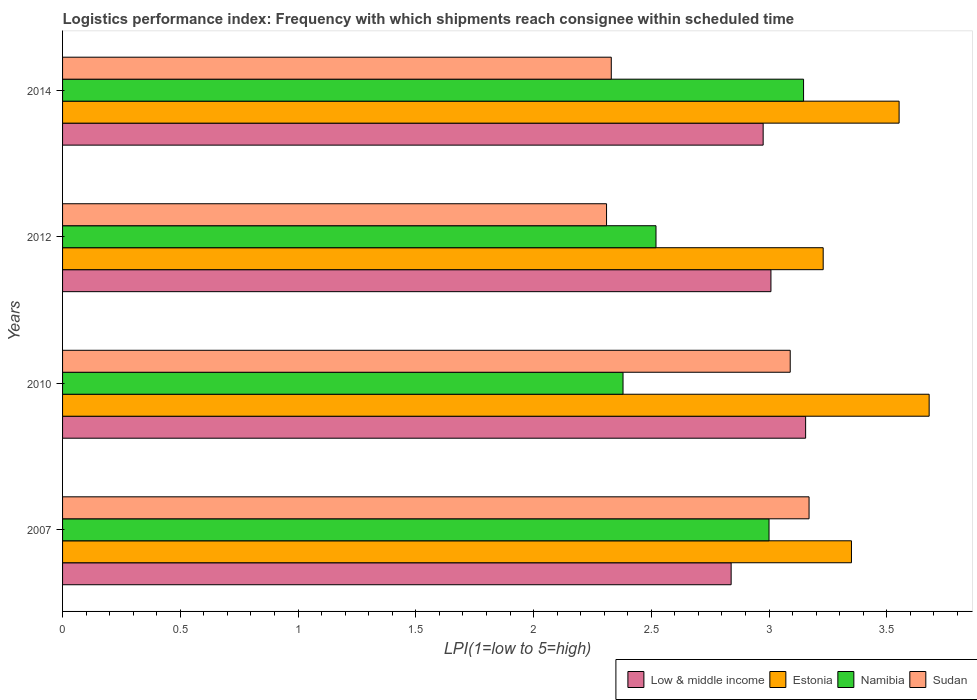How many groups of bars are there?
Your answer should be compact. 4. Are the number of bars per tick equal to the number of legend labels?
Give a very brief answer. Yes. How many bars are there on the 3rd tick from the bottom?
Keep it short and to the point. 4. What is the label of the 3rd group of bars from the top?
Ensure brevity in your answer.  2010. In how many cases, is the number of bars for a given year not equal to the number of legend labels?
Keep it short and to the point. 0. What is the logistics performance index in Estonia in 2014?
Make the answer very short. 3.55. Across all years, what is the maximum logistics performance index in Sudan?
Provide a succinct answer. 3.17. Across all years, what is the minimum logistics performance index in Namibia?
Provide a succinct answer. 2.38. In which year was the logistics performance index in Estonia maximum?
Offer a very short reply. 2010. What is the total logistics performance index in Sudan in the graph?
Your response must be concise. 10.9. What is the difference between the logistics performance index in Namibia in 2010 and that in 2012?
Provide a short and direct response. -0.14. What is the difference between the logistics performance index in Low & middle income in 2007 and the logistics performance index in Namibia in 2012?
Your answer should be very brief. 0.32. What is the average logistics performance index in Estonia per year?
Your answer should be very brief. 3.45. In the year 2014, what is the difference between the logistics performance index in Sudan and logistics performance index in Estonia?
Your response must be concise. -1.22. What is the ratio of the logistics performance index in Namibia in 2007 to that in 2012?
Provide a succinct answer. 1.19. Is the difference between the logistics performance index in Sudan in 2007 and 2010 greater than the difference between the logistics performance index in Estonia in 2007 and 2010?
Keep it short and to the point. Yes. What is the difference between the highest and the second highest logistics performance index in Estonia?
Ensure brevity in your answer.  0.13. What is the difference between the highest and the lowest logistics performance index in Sudan?
Your response must be concise. 0.86. In how many years, is the logistics performance index in Sudan greater than the average logistics performance index in Sudan taken over all years?
Offer a very short reply. 2. Is it the case that in every year, the sum of the logistics performance index in Low & middle income and logistics performance index in Sudan is greater than the sum of logistics performance index in Namibia and logistics performance index in Estonia?
Make the answer very short. No. What does the 2nd bar from the top in 2010 represents?
Offer a very short reply. Namibia. What does the 2nd bar from the bottom in 2010 represents?
Give a very brief answer. Estonia. Is it the case that in every year, the sum of the logistics performance index in Low & middle income and logistics performance index in Sudan is greater than the logistics performance index in Namibia?
Offer a very short reply. Yes. How many bars are there?
Your response must be concise. 16. Are the values on the major ticks of X-axis written in scientific E-notation?
Your answer should be compact. No. Does the graph contain grids?
Your answer should be very brief. No. Where does the legend appear in the graph?
Give a very brief answer. Bottom right. What is the title of the graph?
Your answer should be very brief. Logistics performance index: Frequency with which shipments reach consignee within scheduled time. What is the label or title of the X-axis?
Keep it short and to the point. LPI(1=low to 5=high). What is the label or title of the Y-axis?
Your response must be concise. Years. What is the LPI(1=low to 5=high) in Low & middle income in 2007?
Provide a succinct answer. 2.84. What is the LPI(1=low to 5=high) of Estonia in 2007?
Your response must be concise. 3.35. What is the LPI(1=low to 5=high) in Namibia in 2007?
Give a very brief answer. 3. What is the LPI(1=low to 5=high) in Sudan in 2007?
Provide a short and direct response. 3.17. What is the LPI(1=low to 5=high) of Low & middle income in 2010?
Keep it short and to the point. 3.16. What is the LPI(1=low to 5=high) in Estonia in 2010?
Make the answer very short. 3.68. What is the LPI(1=low to 5=high) in Namibia in 2010?
Offer a very short reply. 2.38. What is the LPI(1=low to 5=high) of Sudan in 2010?
Ensure brevity in your answer.  3.09. What is the LPI(1=low to 5=high) of Low & middle income in 2012?
Make the answer very short. 3.01. What is the LPI(1=low to 5=high) of Estonia in 2012?
Provide a succinct answer. 3.23. What is the LPI(1=low to 5=high) of Namibia in 2012?
Give a very brief answer. 2.52. What is the LPI(1=low to 5=high) in Sudan in 2012?
Provide a succinct answer. 2.31. What is the LPI(1=low to 5=high) in Low & middle income in 2014?
Provide a short and direct response. 2.98. What is the LPI(1=low to 5=high) of Estonia in 2014?
Ensure brevity in your answer.  3.55. What is the LPI(1=low to 5=high) of Namibia in 2014?
Offer a very short reply. 3.15. What is the LPI(1=low to 5=high) in Sudan in 2014?
Give a very brief answer. 2.33. Across all years, what is the maximum LPI(1=low to 5=high) in Low & middle income?
Ensure brevity in your answer.  3.16. Across all years, what is the maximum LPI(1=low to 5=high) of Estonia?
Your answer should be compact. 3.68. Across all years, what is the maximum LPI(1=low to 5=high) of Namibia?
Give a very brief answer. 3.15. Across all years, what is the maximum LPI(1=low to 5=high) of Sudan?
Make the answer very short. 3.17. Across all years, what is the minimum LPI(1=low to 5=high) of Low & middle income?
Provide a short and direct response. 2.84. Across all years, what is the minimum LPI(1=low to 5=high) in Estonia?
Your answer should be very brief. 3.23. Across all years, what is the minimum LPI(1=low to 5=high) of Namibia?
Offer a very short reply. 2.38. Across all years, what is the minimum LPI(1=low to 5=high) in Sudan?
Keep it short and to the point. 2.31. What is the total LPI(1=low to 5=high) of Low & middle income in the graph?
Provide a short and direct response. 11.98. What is the total LPI(1=low to 5=high) of Estonia in the graph?
Your answer should be very brief. 13.81. What is the total LPI(1=low to 5=high) of Namibia in the graph?
Make the answer very short. 11.05. What is the total LPI(1=low to 5=high) of Sudan in the graph?
Give a very brief answer. 10.9. What is the difference between the LPI(1=low to 5=high) of Low & middle income in 2007 and that in 2010?
Offer a very short reply. -0.32. What is the difference between the LPI(1=low to 5=high) of Estonia in 2007 and that in 2010?
Provide a succinct answer. -0.33. What is the difference between the LPI(1=low to 5=high) in Namibia in 2007 and that in 2010?
Ensure brevity in your answer.  0.62. What is the difference between the LPI(1=low to 5=high) of Sudan in 2007 and that in 2010?
Your answer should be very brief. 0.08. What is the difference between the LPI(1=low to 5=high) of Low & middle income in 2007 and that in 2012?
Offer a very short reply. -0.17. What is the difference between the LPI(1=low to 5=high) of Estonia in 2007 and that in 2012?
Your answer should be very brief. 0.12. What is the difference between the LPI(1=low to 5=high) of Namibia in 2007 and that in 2012?
Offer a very short reply. 0.48. What is the difference between the LPI(1=low to 5=high) in Sudan in 2007 and that in 2012?
Provide a short and direct response. 0.86. What is the difference between the LPI(1=low to 5=high) in Low & middle income in 2007 and that in 2014?
Provide a succinct answer. -0.14. What is the difference between the LPI(1=low to 5=high) in Estonia in 2007 and that in 2014?
Your response must be concise. -0.2. What is the difference between the LPI(1=low to 5=high) of Namibia in 2007 and that in 2014?
Your answer should be very brief. -0.15. What is the difference between the LPI(1=low to 5=high) of Sudan in 2007 and that in 2014?
Your answer should be very brief. 0.84. What is the difference between the LPI(1=low to 5=high) of Low & middle income in 2010 and that in 2012?
Your answer should be very brief. 0.15. What is the difference between the LPI(1=low to 5=high) of Estonia in 2010 and that in 2012?
Offer a very short reply. 0.45. What is the difference between the LPI(1=low to 5=high) of Namibia in 2010 and that in 2012?
Your response must be concise. -0.14. What is the difference between the LPI(1=low to 5=high) of Sudan in 2010 and that in 2012?
Your answer should be compact. 0.78. What is the difference between the LPI(1=low to 5=high) in Low & middle income in 2010 and that in 2014?
Your response must be concise. 0.18. What is the difference between the LPI(1=low to 5=high) in Estonia in 2010 and that in 2014?
Your answer should be compact. 0.13. What is the difference between the LPI(1=low to 5=high) in Namibia in 2010 and that in 2014?
Keep it short and to the point. -0.77. What is the difference between the LPI(1=low to 5=high) in Sudan in 2010 and that in 2014?
Give a very brief answer. 0.76. What is the difference between the LPI(1=low to 5=high) in Low & middle income in 2012 and that in 2014?
Offer a terse response. 0.03. What is the difference between the LPI(1=low to 5=high) in Estonia in 2012 and that in 2014?
Provide a succinct answer. -0.32. What is the difference between the LPI(1=low to 5=high) in Namibia in 2012 and that in 2014?
Your answer should be compact. -0.63. What is the difference between the LPI(1=low to 5=high) in Sudan in 2012 and that in 2014?
Give a very brief answer. -0.02. What is the difference between the LPI(1=low to 5=high) of Low & middle income in 2007 and the LPI(1=low to 5=high) of Estonia in 2010?
Keep it short and to the point. -0.84. What is the difference between the LPI(1=low to 5=high) of Low & middle income in 2007 and the LPI(1=low to 5=high) of Namibia in 2010?
Give a very brief answer. 0.46. What is the difference between the LPI(1=low to 5=high) in Low & middle income in 2007 and the LPI(1=low to 5=high) in Sudan in 2010?
Your response must be concise. -0.25. What is the difference between the LPI(1=low to 5=high) of Estonia in 2007 and the LPI(1=low to 5=high) of Sudan in 2010?
Keep it short and to the point. 0.26. What is the difference between the LPI(1=low to 5=high) of Namibia in 2007 and the LPI(1=low to 5=high) of Sudan in 2010?
Your response must be concise. -0.09. What is the difference between the LPI(1=low to 5=high) of Low & middle income in 2007 and the LPI(1=low to 5=high) of Estonia in 2012?
Your response must be concise. -0.39. What is the difference between the LPI(1=low to 5=high) of Low & middle income in 2007 and the LPI(1=low to 5=high) of Namibia in 2012?
Keep it short and to the point. 0.32. What is the difference between the LPI(1=low to 5=high) of Low & middle income in 2007 and the LPI(1=low to 5=high) of Sudan in 2012?
Provide a succinct answer. 0.53. What is the difference between the LPI(1=low to 5=high) of Estonia in 2007 and the LPI(1=low to 5=high) of Namibia in 2012?
Give a very brief answer. 0.83. What is the difference between the LPI(1=low to 5=high) of Namibia in 2007 and the LPI(1=low to 5=high) of Sudan in 2012?
Your answer should be compact. 0.69. What is the difference between the LPI(1=low to 5=high) in Low & middle income in 2007 and the LPI(1=low to 5=high) in Estonia in 2014?
Offer a very short reply. -0.71. What is the difference between the LPI(1=low to 5=high) of Low & middle income in 2007 and the LPI(1=low to 5=high) of Namibia in 2014?
Ensure brevity in your answer.  -0.31. What is the difference between the LPI(1=low to 5=high) in Low & middle income in 2007 and the LPI(1=low to 5=high) in Sudan in 2014?
Give a very brief answer. 0.51. What is the difference between the LPI(1=low to 5=high) in Estonia in 2007 and the LPI(1=low to 5=high) in Namibia in 2014?
Your answer should be compact. 0.2. What is the difference between the LPI(1=low to 5=high) of Estonia in 2007 and the LPI(1=low to 5=high) of Sudan in 2014?
Your response must be concise. 1.02. What is the difference between the LPI(1=low to 5=high) in Namibia in 2007 and the LPI(1=low to 5=high) in Sudan in 2014?
Your answer should be very brief. 0.67. What is the difference between the LPI(1=low to 5=high) of Low & middle income in 2010 and the LPI(1=low to 5=high) of Estonia in 2012?
Offer a terse response. -0.07. What is the difference between the LPI(1=low to 5=high) in Low & middle income in 2010 and the LPI(1=low to 5=high) in Namibia in 2012?
Make the answer very short. 0.64. What is the difference between the LPI(1=low to 5=high) of Low & middle income in 2010 and the LPI(1=low to 5=high) of Sudan in 2012?
Provide a succinct answer. 0.85. What is the difference between the LPI(1=low to 5=high) in Estonia in 2010 and the LPI(1=low to 5=high) in Namibia in 2012?
Your answer should be compact. 1.16. What is the difference between the LPI(1=low to 5=high) in Estonia in 2010 and the LPI(1=low to 5=high) in Sudan in 2012?
Your answer should be compact. 1.37. What is the difference between the LPI(1=low to 5=high) of Namibia in 2010 and the LPI(1=low to 5=high) of Sudan in 2012?
Provide a short and direct response. 0.07. What is the difference between the LPI(1=low to 5=high) in Low & middle income in 2010 and the LPI(1=low to 5=high) in Estonia in 2014?
Your answer should be very brief. -0.4. What is the difference between the LPI(1=low to 5=high) of Low & middle income in 2010 and the LPI(1=low to 5=high) of Namibia in 2014?
Make the answer very short. 0.01. What is the difference between the LPI(1=low to 5=high) in Low & middle income in 2010 and the LPI(1=low to 5=high) in Sudan in 2014?
Your answer should be very brief. 0.83. What is the difference between the LPI(1=low to 5=high) of Estonia in 2010 and the LPI(1=low to 5=high) of Namibia in 2014?
Your response must be concise. 0.53. What is the difference between the LPI(1=low to 5=high) in Estonia in 2010 and the LPI(1=low to 5=high) in Sudan in 2014?
Ensure brevity in your answer.  1.35. What is the difference between the LPI(1=low to 5=high) of Namibia in 2010 and the LPI(1=low to 5=high) of Sudan in 2014?
Your answer should be very brief. 0.05. What is the difference between the LPI(1=low to 5=high) in Low & middle income in 2012 and the LPI(1=low to 5=high) in Estonia in 2014?
Provide a succinct answer. -0.54. What is the difference between the LPI(1=low to 5=high) of Low & middle income in 2012 and the LPI(1=low to 5=high) of Namibia in 2014?
Offer a terse response. -0.14. What is the difference between the LPI(1=low to 5=high) of Low & middle income in 2012 and the LPI(1=low to 5=high) of Sudan in 2014?
Keep it short and to the point. 0.68. What is the difference between the LPI(1=low to 5=high) in Estonia in 2012 and the LPI(1=low to 5=high) in Namibia in 2014?
Offer a very short reply. 0.08. What is the difference between the LPI(1=low to 5=high) in Estonia in 2012 and the LPI(1=low to 5=high) in Sudan in 2014?
Your answer should be very brief. 0.9. What is the difference between the LPI(1=low to 5=high) in Namibia in 2012 and the LPI(1=low to 5=high) in Sudan in 2014?
Offer a terse response. 0.19. What is the average LPI(1=low to 5=high) in Low & middle income per year?
Provide a succinct answer. 2.99. What is the average LPI(1=low to 5=high) of Estonia per year?
Your answer should be compact. 3.45. What is the average LPI(1=low to 5=high) of Namibia per year?
Your answer should be very brief. 2.76. What is the average LPI(1=low to 5=high) in Sudan per year?
Provide a succinct answer. 2.73. In the year 2007, what is the difference between the LPI(1=low to 5=high) of Low & middle income and LPI(1=low to 5=high) of Estonia?
Keep it short and to the point. -0.51. In the year 2007, what is the difference between the LPI(1=low to 5=high) in Low & middle income and LPI(1=low to 5=high) in Namibia?
Keep it short and to the point. -0.16. In the year 2007, what is the difference between the LPI(1=low to 5=high) in Low & middle income and LPI(1=low to 5=high) in Sudan?
Ensure brevity in your answer.  -0.33. In the year 2007, what is the difference between the LPI(1=low to 5=high) of Estonia and LPI(1=low to 5=high) of Namibia?
Make the answer very short. 0.35. In the year 2007, what is the difference between the LPI(1=low to 5=high) of Estonia and LPI(1=low to 5=high) of Sudan?
Offer a terse response. 0.18. In the year 2007, what is the difference between the LPI(1=low to 5=high) of Namibia and LPI(1=low to 5=high) of Sudan?
Provide a short and direct response. -0.17. In the year 2010, what is the difference between the LPI(1=low to 5=high) of Low & middle income and LPI(1=low to 5=high) of Estonia?
Provide a short and direct response. -0.52. In the year 2010, what is the difference between the LPI(1=low to 5=high) of Low & middle income and LPI(1=low to 5=high) of Namibia?
Offer a very short reply. 0.78. In the year 2010, what is the difference between the LPI(1=low to 5=high) in Low & middle income and LPI(1=low to 5=high) in Sudan?
Your answer should be compact. 0.07. In the year 2010, what is the difference between the LPI(1=low to 5=high) in Estonia and LPI(1=low to 5=high) in Namibia?
Provide a short and direct response. 1.3. In the year 2010, what is the difference between the LPI(1=low to 5=high) in Estonia and LPI(1=low to 5=high) in Sudan?
Your response must be concise. 0.59. In the year 2010, what is the difference between the LPI(1=low to 5=high) of Namibia and LPI(1=low to 5=high) of Sudan?
Give a very brief answer. -0.71. In the year 2012, what is the difference between the LPI(1=low to 5=high) of Low & middle income and LPI(1=low to 5=high) of Estonia?
Ensure brevity in your answer.  -0.22. In the year 2012, what is the difference between the LPI(1=low to 5=high) in Low & middle income and LPI(1=low to 5=high) in Namibia?
Make the answer very short. 0.49. In the year 2012, what is the difference between the LPI(1=low to 5=high) of Low & middle income and LPI(1=low to 5=high) of Sudan?
Your response must be concise. 0.7. In the year 2012, what is the difference between the LPI(1=low to 5=high) in Estonia and LPI(1=low to 5=high) in Namibia?
Offer a very short reply. 0.71. In the year 2012, what is the difference between the LPI(1=low to 5=high) of Namibia and LPI(1=low to 5=high) of Sudan?
Offer a terse response. 0.21. In the year 2014, what is the difference between the LPI(1=low to 5=high) in Low & middle income and LPI(1=low to 5=high) in Estonia?
Offer a terse response. -0.58. In the year 2014, what is the difference between the LPI(1=low to 5=high) in Low & middle income and LPI(1=low to 5=high) in Namibia?
Keep it short and to the point. -0.17. In the year 2014, what is the difference between the LPI(1=low to 5=high) of Low & middle income and LPI(1=low to 5=high) of Sudan?
Give a very brief answer. 0.65. In the year 2014, what is the difference between the LPI(1=low to 5=high) in Estonia and LPI(1=low to 5=high) in Namibia?
Offer a terse response. 0.41. In the year 2014, what is the difference between the LPI(1=low to 5=high) of Estonia and LPI(1=low to 5=high) of Sudan?
Your response must be concise. 1.22. In the year 2014, what is the difference between the LPI(1=low to 5=high) in Namibia and LPI(1=low to 5=high) in Sudan?
Offer a terse response. 0.82. What is the ratio of the LPI(1=low to 5=high) of Low & middle income in 2007 to that in 2010?
Provide a succinct answer. 0.9. What is the ratio of the LPI(1=low to 5=high) in Estonia in 2007 to that in 2010?
Ensure brevity in your answer.  0.91. What is the ratio of the LPI(1=low to 5=high) in Namibia in 2007 to that in 2010?
Give a very brief answer. 1.26. What is the ratio of the LPI(1=low to 5=high) in Sudan in 2007 to that in 2010?
Your answer should be compact. 1.03. What is the ratio of the LPI(1=low to 5=high) in Low & middle income in 2007 to that in 2012?
Your response must be concise. 0.94. What is the ratio of the LPI(1=low to 5=high) in Estonia in 2007 to that in 2012?
Make the answer very short. 1.04. What is the ratio of the LPI(1=low to 5=high) of Namibia in 2007 to that in 2012?
Provide a succinct answer. 1.19. What is the ratio of the LPI(1=low to 5=high) of Sudan in 2007 to that in 2012?
Your response must be concise. 1.37. What is the ratio of the LPI(1=low to 5=high) of Low & middle income in 2007 to that in 2014?
Give a very brief answer. 0.95. What is the ratio of the LPI(1=low to 5=high) in Estonia in 2007 to that in 2014?
Your response must be concise. 0.94. What is the ratio of the LPI(1=low to 5=high) of Namibia in 2007 to that in 2014?
Your answer should be very brief. 0.95. What is the ratio of the LPI(1=low to 5=high) in Sudan in 2007 to that in 2014?
Provide a short and direct response. 1.36. What is the ratio of the LPI(1=low to 5=high) of Low & middle income in 2010 to that in 2012?
Your answer should be very brief. 1.05. What is the ratio of the LPI(1=low to 5=high) in Estonia in 2010 to that in 2012?
Your response must be concise. 1.14. What is the ratio of the LPI(1=low to 5=high) of Sudan in 2010 to that in 2012?
Provide a succinct answer. 1.34. What is the ratio of the LPI(1=low to 5=high) of Low & middle income in 2010 to that in 2014?
Your response must be concise. 1.06. What is the ratio of the LPI(1=low to 5=high) of Estonia in 2010 to that in 2014?
Make the answer very short. 1.04. What is the ratio of the LPI(1=low to 5=high) in Namibia in 2010 to that in 2014?
Ensure brevity in your answer.  0.76. What is the ratio of the LPI(1=low to 5=high) in Sudan in 2010 to that in 2014?
Your answer should be very brief. 1.33. What is the ratio of the LPI(1=low to 5=high) in Low & middle income in 2012 to that in 2014?
Keep it short and to the point. 1.01. What is the ratio of the LPI(1=low to 5=high) in Estonia in 2012 to that in 2014?
Your answer should be compact. 0.91. What is the ratio of the LPI(1=low to 5=high) of Namibia in 2012 to that in 2014?
Your answer should be very brief. 0.8. What is the difference between the highest and the second highest LPI(1=low to 5=high) of Low & middle income?
Keep it short and to the point. 0.15. What is the difference between the highest and the second highest LPI(1=low to 5=high) of Estonia?
Make the answer very short. 0.13. What is the difference between the highest and the second highest LPI(1=low to 5=high) of Namibia?
Ensure brevity in your answer.  0.15. What is the difference between the highest and the second highest LPI(1=low to 5=high) in Sudan?
Offer a very short reply. 0.08. What is the difference between the highest and the lowest LPI(1=low to 5=high) in Low & middle income?
Your response must be concise. 0.32. What is the difference between the highest and the lowest LPI(1=low to 5=high) in Estonia?
Give a very brief answer. 0.45. What is the difference between the highest and the lowest LPI(1=low to 5=high) in Namibia?
Give a very brief answer. 0.77. What is the difference between the highest and the lowest LPI(1=low to 5=high) in Sudan?
Give a very brief answer. 0.86. 